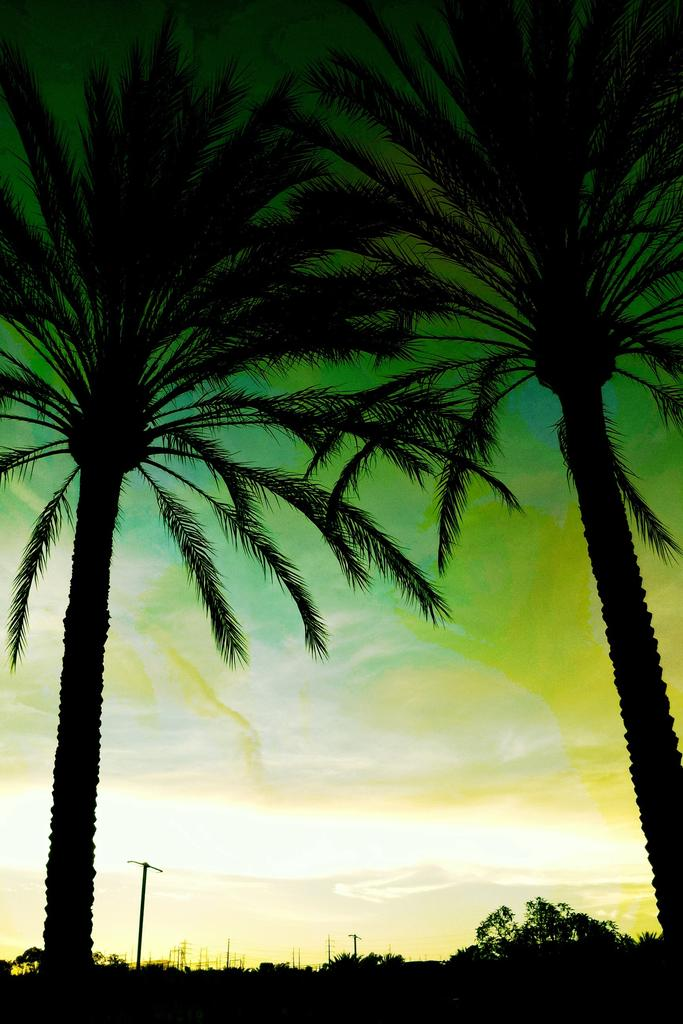What type of vegetation is present at the bottom side of the image? There are trees at the bottom side of the image. What else can be seen at the bottom side of the image? There are poles at the bottom side of the image. How many coconut trees are on the right side of the image? There are two coconut trees on the right side of the image. How many coconut trees are on the left side of the image? There are two coconut trees on the left side of the image. How many chairs are visible in the image? There are no chairs present in the image. Is there a chain connecting the coconut trees in the image? There is no chain connecting the coconut trees in the image; the trees are separate entities. 